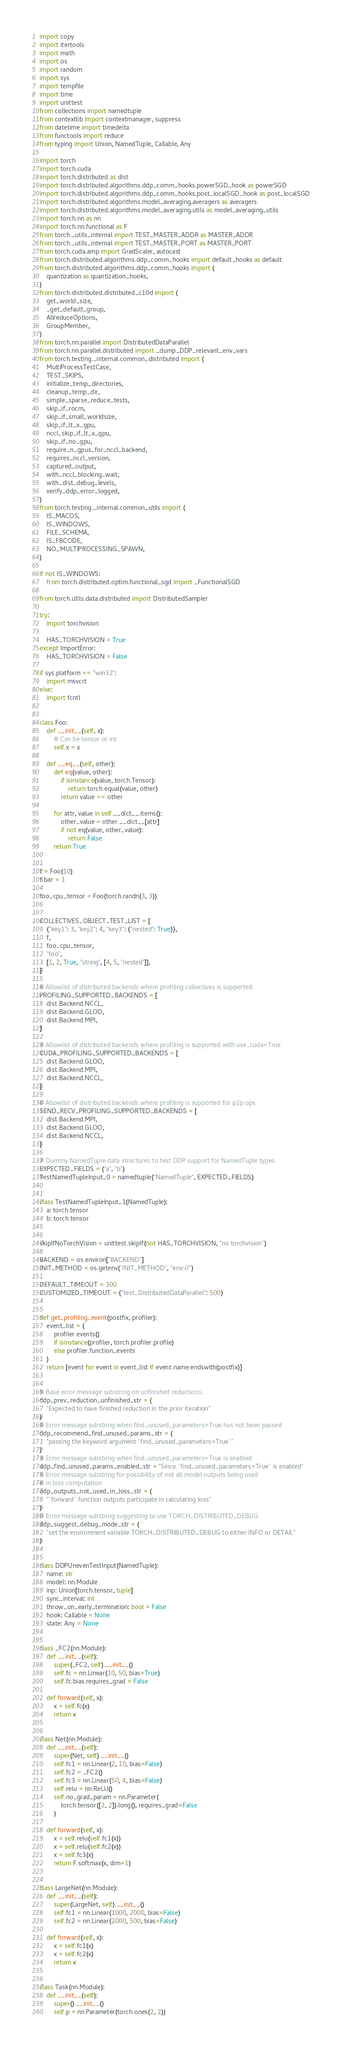<code> <loc_0><loc_0><loc_500><loc_500><_Python_>import copy
import itertools
import math
import os
import random
import sys
import tempfile
import time
import unittest
from collections import namedtuple
from contextlib import contextmanager, suppress
from datetime import timedelta
from functools import reduce
from typing import Union, NamedTuple, Callable, Any

import torch
import torch.cuda
import torch.distributed as dist
import torch.distributed.algorithms.ddp_comm_hooks.powerSGD_hook as powerSGD
import torch.distributed.algorithms.ddp_comm_hooks.post_localSGD_hook as post_localSGD
import torch.distributed.algorithms.model_averaging.averagers as averagers
import torch.distributed.algorithms.model_averaging.utils as model_averaging_utils
import torch.nn as nn
import torch.nn.functional as F
from torch._utils_internal import TEST_MASTER_ADDR as MASTER_ADDR
from torch._utils_internal import TEST_MASTER_PORT as MASTER_PORT
from torch.cuda.amp import GradScaler, autocast
from torch.distributed.algorithms.ddp_comm_hooks import default_hooks as default
from torch.distributed.algorithms.ddp_comm_hooks import (
    quantization as quantization_hooks,
)
from torch.distributed.distributed_c10d import (
    get_world_size,
    _get_default_group,
    AllreduceOptions,
    GroupMember,
)
from torch.nn.parallel import DistributedDataParallel
from torch.nn.parallel.distributed import _dump_DDP_relevant_env_vars
from torch.testing._internal.common_distributed import (
    MultiProcessTestCase,
    TEST_SKIPS,
    initialize_temp_directories,
    cleanup_temp_dir,
    simple_sparse_reduce_tests,
    skip_if_rocm,
    skip_if_small_worldsize,
    skip_if_lt_x_gpu,
    nccl_skip_if_lt_x_gpu,
    skip_if_no_gpu,
    require_n_gpus_for_nccl_backend,
    requires_nccl_version,
    captured_output,
    with_nccl_blocking_wait,
    with_dist_debug_levels,
    verify_ddp_error_logged,
)
from torch.testing._internal.common_utils import (
    IS_MACOS,
    IS_WINDOWS,
    FILE_SCHEMA,
    IS_FBCODE,
    NO_MULTIPROCESSING_SPAWN,
)

if not IS_WINDOWS:
    from torch.distributed.optim.functional_sgd import _FunctionalSGD

from torch.utils.data.distributed import DistributedSampler

try:
    import torchvision

    HAS_TORCHVISION = True
except ImportError:
    HAS_TORCHVISION = False

if sys.platform == "win32":
    import msvcrt
else:
    import fcntl


class Foo:
    def __init__(self, x):
        # Can be tensor or int
        self.x = x

    def __eq__(self, other):
        def eq(value, other):
            if isinstance(value, torch.Tensor):
                return torch.equal(value, other)
            return value == other

        for attr, value in self.__dict__.items():
            other_value = other.__dict__[attr]
            if not eq(value, other_value):
                return False
        return True


f = Foo(10)
f.bar = 1

foo_cpu_tensor = Foo(torch.randn(3, 3))


COLLECTIVES_OBJECT_TEST_LIST = [
    {"key1": 3, "key2": 4, "key3": {"nested": True}},
    f,
    foo_cpu_tensor,
    "foo",
    [1, 2, True, "string", [4, 5, "nested"]],
]

# Allowlist of distributed backends where profiling collectives is supported.
PROFILING_SUPPORTED_BACKENDS = [
    dist.Backend.NCCL,
    dist.Backend.GLOO,
    dist.Backend.MPI,
]

# Allowlist of distributed backends where profiling is supported with use_cuda=True
CUDA_PROFILING_SUPPORTED_BACKENDS = [
    dist.Backend.GLOO,
    dist.Backend.MPI,
    dist.Backend.NCCL,
]

# Allowlist of distributed backends where profiling is supported for p2p ops
SEND_RECV_PROFILING_SUPPORTED_BACKENDS = [
    dist.Backend.MPI,
    dist.Backend.GLOO,
    dist.Backend.NCCL,
]

# Dummy NamedTuple data structures to test DDP support for NamedTuple types.
EXPECTED_FIELDS = ("a", "b")
TestNamedTupleInput_0 = namedtuple("NamedTuple", EXPECTED_FIELDS)


class TestNamedTupleInput_1(NamedTuple):
    a: torch.tensor
    b: torch.tensor


skipIfNoTorchVision = unittest.skipIf(not HAS_TORCHVISION, "no torchvision")

BACKEND = os.environ["BACKEND"]
INIT_METHOD = os.getenv("INIT_METHOD", "env://")

DEFAULT_TIMEOUT = 300
CUSTOMIZED_TIMEOUT = {"test_DistributedDataParallel": 500}


def get_profiling_event(postfix, profiler):
    event_list = (
        profiler.events()
        if isinstance(profiler, torch.profiler.profile)
        else profiler.function_events
    )
    return [event for event in event_list if event.name.endswith(postfix)]


# Base error message substring on unfinished reductions.
ddp_prev_reduction_unfinished_str = (
    "Expected to have finished reduction in the prior iteration"
)
# Error message substring when find_unused_parameters=True has not been passed
ddp_recommend_find_unused_params_str = (
    "passing the keyword argument `find_unused_parameters=True`"
)
# Error message substring when find_unused_parameters=True is enabled
ddp_find_unused_params_enabled_str = "Since `find_unused_parameters=True` is enabled"
# Error message substring for possibility of not all model outputs being used
# in loss computation
ddp_outputs_not_used_in_loss_str = (
    "`forward` function outputs participate in calculating loss"
)
# Error message substring suggesting to use TORCH_DISTRIBUTED_DEBUG
ddp_suggest_debug_mode_str = (
    "set the environment variable TORCH_DISTRIBUTED_DEBUG to either INFO or DETAIL"
)


class DDPUnevenTestInput(NamedTuple):
    name: str
    model: nn.Module
    inp: Union[torch.tensor, tuple]
    sync_interval: int
    throw_on_early_termination: bool = False
    hook: Callable = None
    state: Any = None


class _FC2(nn.Module):
    def __init__(self):
        super(_FC2, self).__init__()
        self.fc = nn.Linear(10, 50, bias=True)
        self.fc.bias.requires_grad = False

    def forward(self, x):
        x = self.fc(x)
        return x


class Net(nn.Module):
    def __init__(self):
        super(Net, self).__init__()
        self.fc1 = nn.Linear(2, 10, bias=False)
        self.fc2 = _FC2()
        self.fc3 = nn.Linear(50, 4, bias=False)
        self.relu = nn.ReLU()
        self.no_grad_param = nn.Parameter(
            torch.tensor([2, 2]).long(), requires_grad=False
        )

    def forward(self, x):
        x = self.relu(self.fc1(x))
        x = self.relu(self.fc2(x))
        x = self.fc3(x)
        return F.softmax(x, dim=1)


class LargeNet(nn.Module):
    def __init__(self):
        super(LargeNet, self).__init__()
        self.fc1 = nn.Linear(1000, 2000, bias=False)
        self.fc2 = nn.Linear(2000, 500, bias=False)

    def forward(self, x):
        x = self.fc1(x)
        x = self.fc2(x)
        return x


class Task(nn.Module):
    def __init__(self):
        super().__init__()
        self.p = nn.Parameter(torch.ones(2, 2))
</code> 